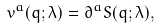Convert formula to latex. <formula><loc_0><loc_0><loc_500><loc_500>v ^ { a } ( q ; \lambda ) = \partial ^ { a } S ( q ; \lambda ) ,</formula> 